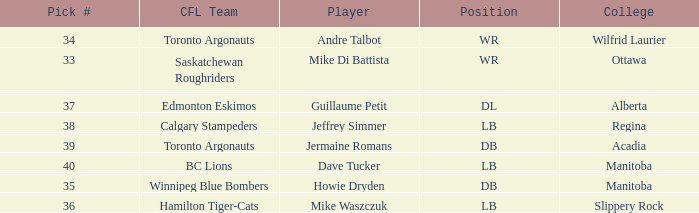What Player has a College that is alberta? Guillaume Petit. 